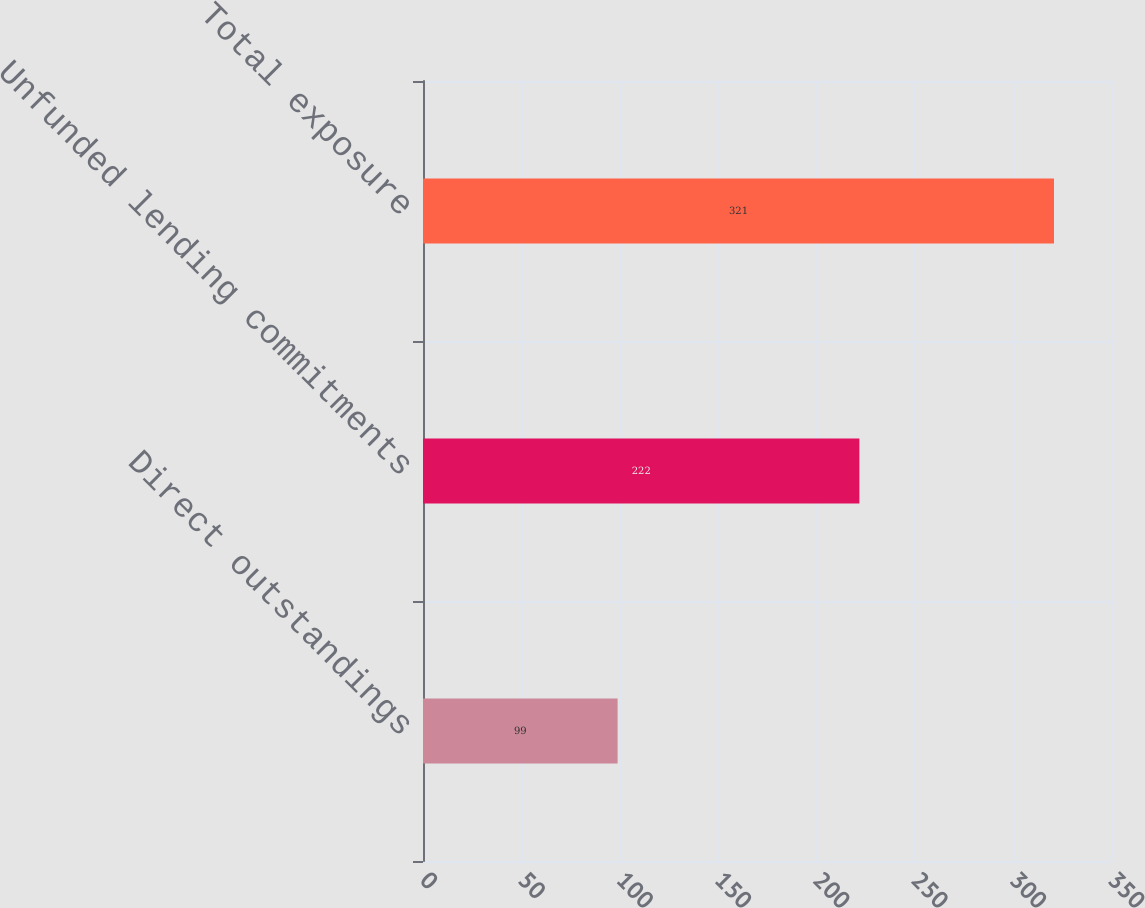Convert chart. <chart><loc_0><loc_0><loc_500><loc_500><bar_chart><fcel>Direct outstandings<fcel>Unfunded lending commitments<fcel>Total exposure<nl><fcel>99<fcel>222<fcel>321<nl></chart> 